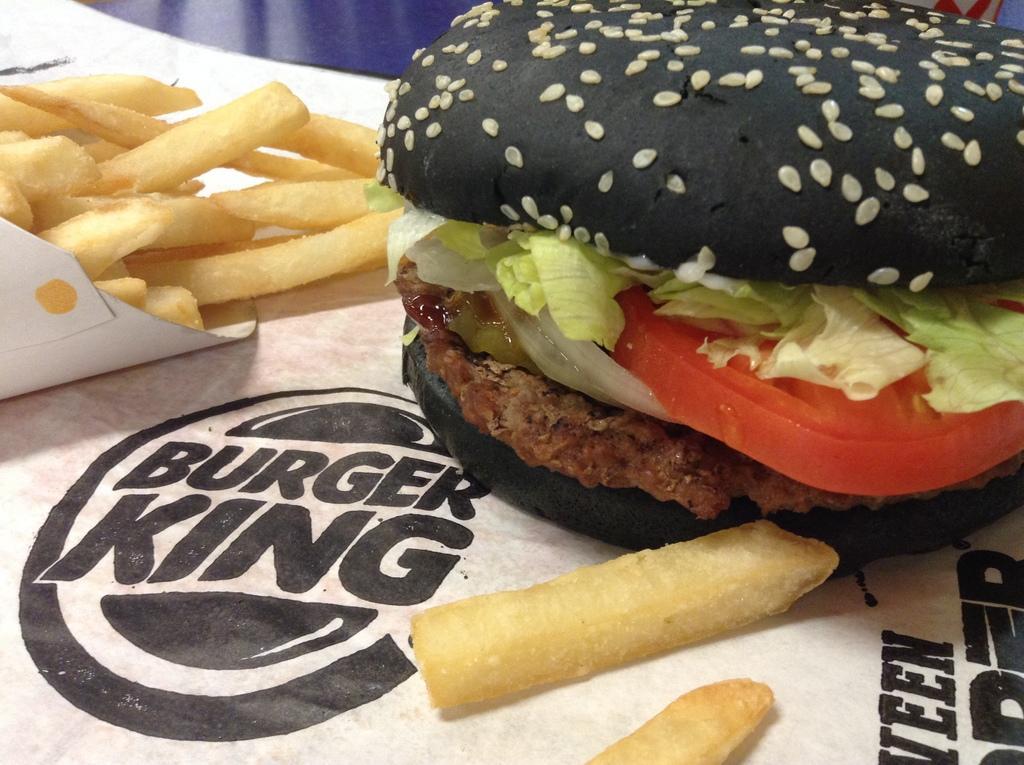Please provide a concise description of this image. In this picture I can see there is a burger with some sesame seeds and it has a tomato slice, a onion slice and some stuffing with sauce. There is a white wrapper placed on the tray and there is a logo on it. 